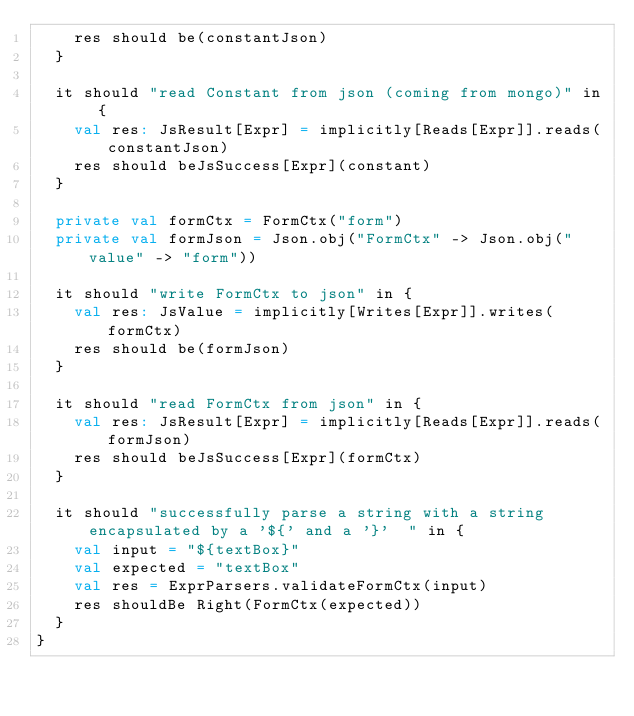<code> <loc_0><loc_0><loc_500><loc_500><_Scala_>    res should be(constantJson)
  }

  it should "read Constant from json (coming from mongo)" in {
    val res: JsResult[Expr] = implicitly[Reads[Expr]].reads(constantJson)
    res should beJsSuccess[Expr](constant)
  }

  private val formCtx = FormCtx("form")
  private val formJson = Json.obj("FormCtx" -> Json.obj("value" -> "form"))

  it should "write FormCtx to json" in {
    val res: JsValue = implicitly[Writes[Expr]].writes(formCtx)
    res should be(formJson)
  }

  it should "read FormCtx from json" in {
    val res: JsResult[Expr] = implicitly[Reads[Expr]].reads(formJson)
    res should beJsSuccess[Expr](formCtx)
  }

  it should "successfully parse a string with a string encapsulated by a '${' and a '}'  " in {
    val input = "${textBox}"
    val expected = "textBox"
    val res = ExprParsers.validateFormCtx(input)
    res shouldBe Right(FormCtx(expected))
  }
}
</code> 